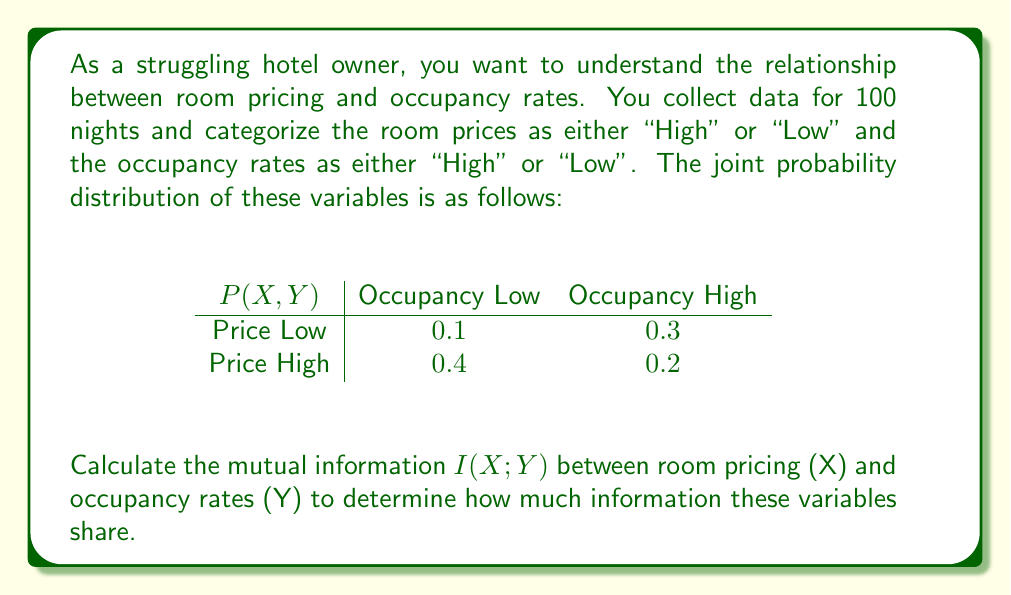Can you answer this question? To calculate the mutual information $I(X;Y)$, we'll follow these steps:

1) First, we need to calculate the marginal probabilities:

   $P(X = \text{Low}) = 0.1 + 0.3 = 0.4$
   $P(X = \text{High}) = 0.4 + 0.2 = 0.6$
   $P(Y = \text{Low}) = 0.1 + 0.4 = 0.5$
   $P(Y = \text{High}) = 0.3 + 0.2 = 0.5$

2) The mutual information is defined as:

   $$I(X;Y) = \sum_{x \in X} \sum_{y \in Y} P(x,y) \log_2 \frac{P(x,y)}{P(x)P(y)}$$

3) Let's calculate each term:

   For $P(\text{Low}, \text{Low})$:
   $$0.1 \log_2 \frac{0.1}{0.4 \cdot 0.5} = 0.1 \log_2 0.5 = -0.1$$

   For $P(\text{Low}, \text{High})$:
   $$0.3 \log_2 \frac{0.3}{0.4 \cdot 0.5} = 0.3 \log_2 1.5 = 0.176$$

   For $P(\text{High}, \text{Low})$:
   $$0.4 \log_2 \frac{0.4}{0.6 \cdot 0.5} = 0.4 \log_2 1.333 = 0.146$$

   For $P(\text{High}, \text{High})$:
   $$0.2 \log_2 \frac{0.2}{0.6 \cdot 0.5} = 0.2 \log_2 0.667 = -0.104$$

4) Sum all these terms:

   $$I(X;Y) = -0.1 + 0.176 + 0.146 - 0.104 = 0.118 \text{ bits}$$
Answer: The mutual information $I(X;Y)$ between room pricing and occupancy rates is approximately 0.118 bits. 